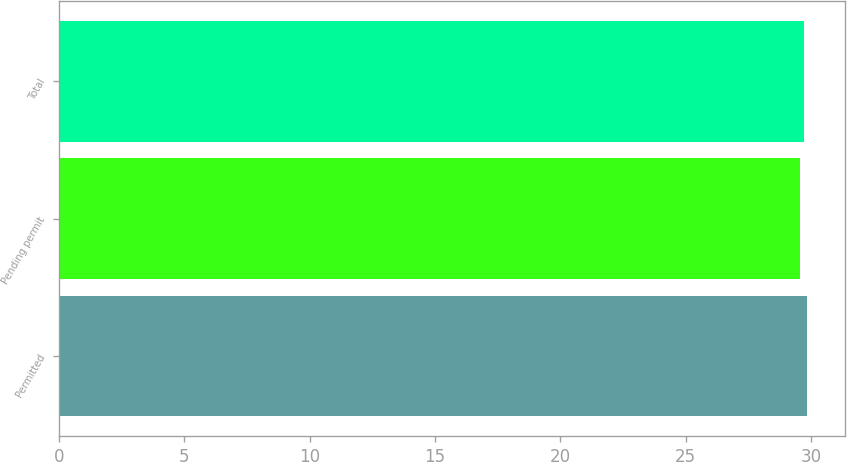<chart> <loc_0><loc_0><loc_500><loc_500><bar_chart><fcel>Permitted<fcel>Pending permit<fcel>Total<nl><fcel>29.84<fcel>29.57<fcel>29.72<nl></chart> 